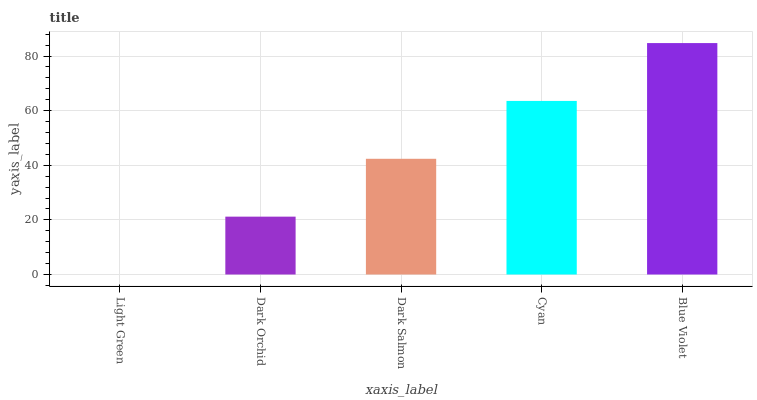Is Light Green the minimum?
Answer yes or no. Yes. Is Blue Violet the maximum?
Answer yes or no. Yes. Is Dark Orchid the minimum?
Answer yes or no. No. Is Dark Orchid the maximum?
Answer yes or no. No. Is Dark Orchid greater than Light Green?
Answer yes or no. Yes. Is Light Green less than Dark Orchid?
Answer yes or no. Yes. Is Light Green greater than Dark Orchid?
Answer yes or no. No. Is Dark Orchid less than Light Green?
Answer yes or no. No. Is Dark Salmon the high median?
Answer yes or no. Yes. Is Dark Salmon the low median?
Answer yes or no. Yes. Is Dark Orchid the high median?
Answer yes or no. No. Is Cyan the low median?
Answer yes or no. No. 